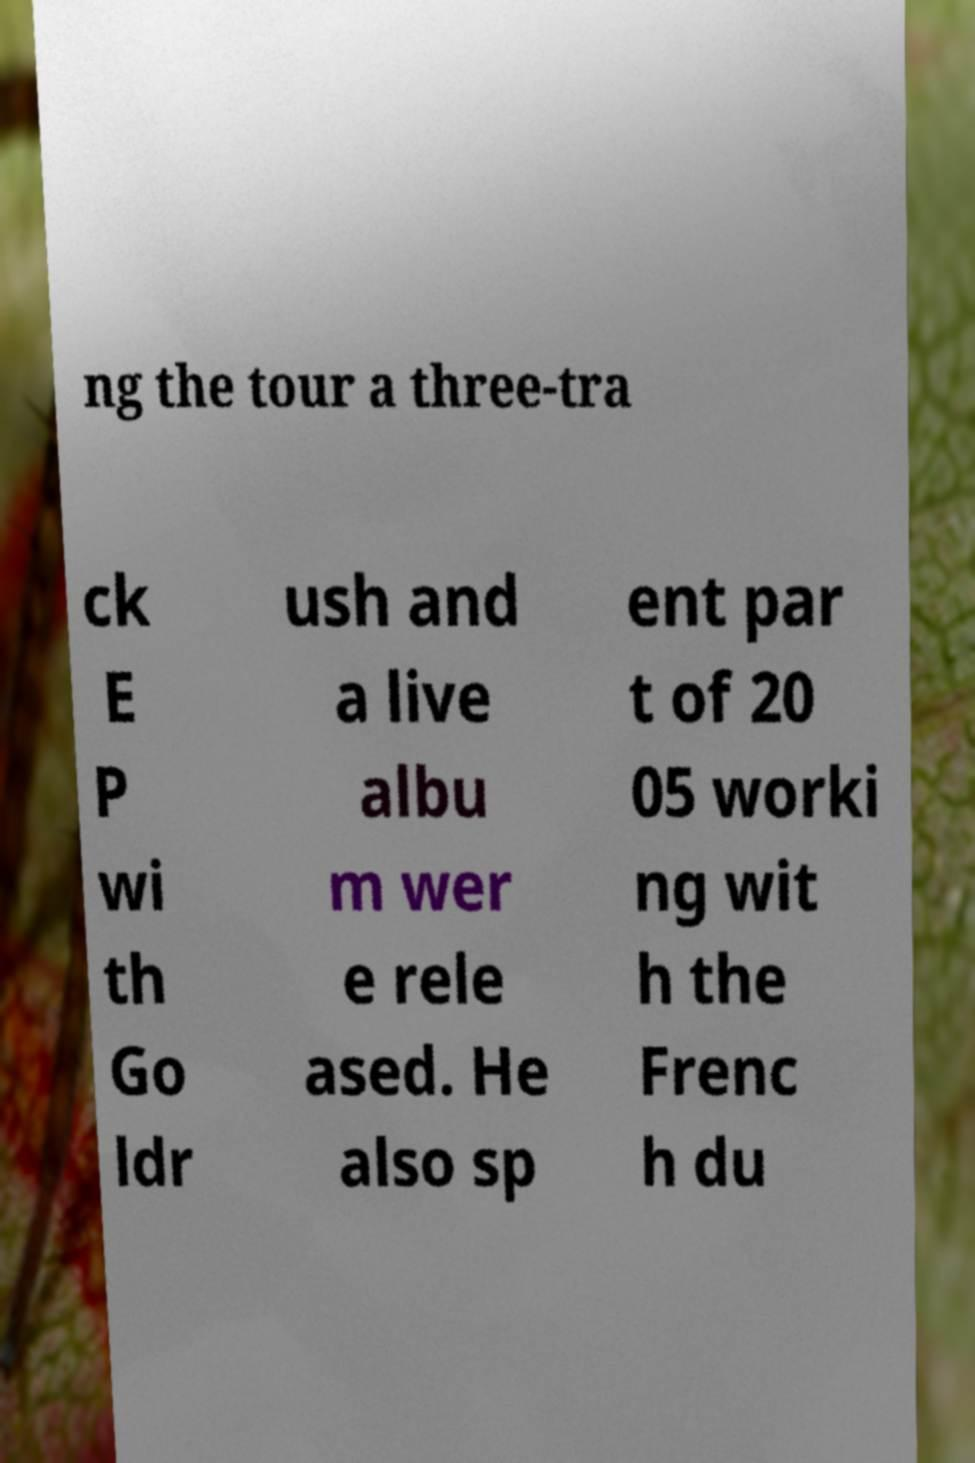Please identify and transcribe the text found in this image. ng the tour a three-tra ck E P wi th Go ldr ush and a live albu m wer e rele ased. He also sp ent par t of 20 05 worki ng wit h the Frenc h du 